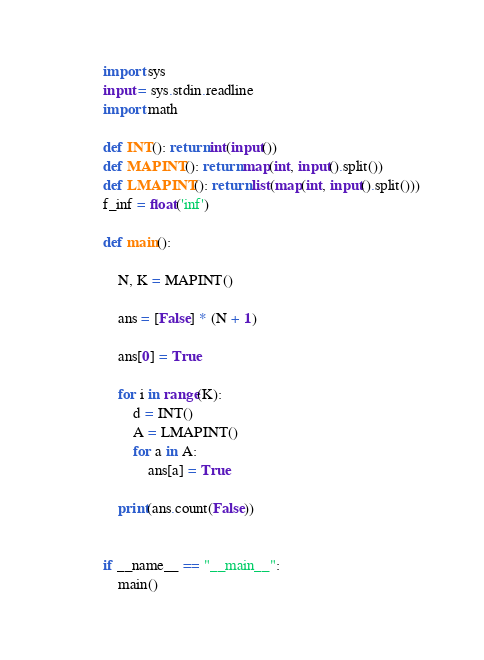Convert code to text. <code><loc_0><loc_0><loc_500><loc_500><_Cython_>import sys
input = sys.stdin.readline
import math

def INT(): return int(input())
def MAPINT(): return map(int, input().split())
def LMAPINT(): return list(map(int, input().split()))
f_inf = float('inf')

def main():

    N, K = MAPINT()

    ans = [False] * (N + 1)

    ans[0] = True

    for i in range(K):
        d = INT()
        A = LMAPINT()
        for a in A:
            ans[a] = True

    print(ans.count(False))


if __name__ == "__main__":
    main()</code> 